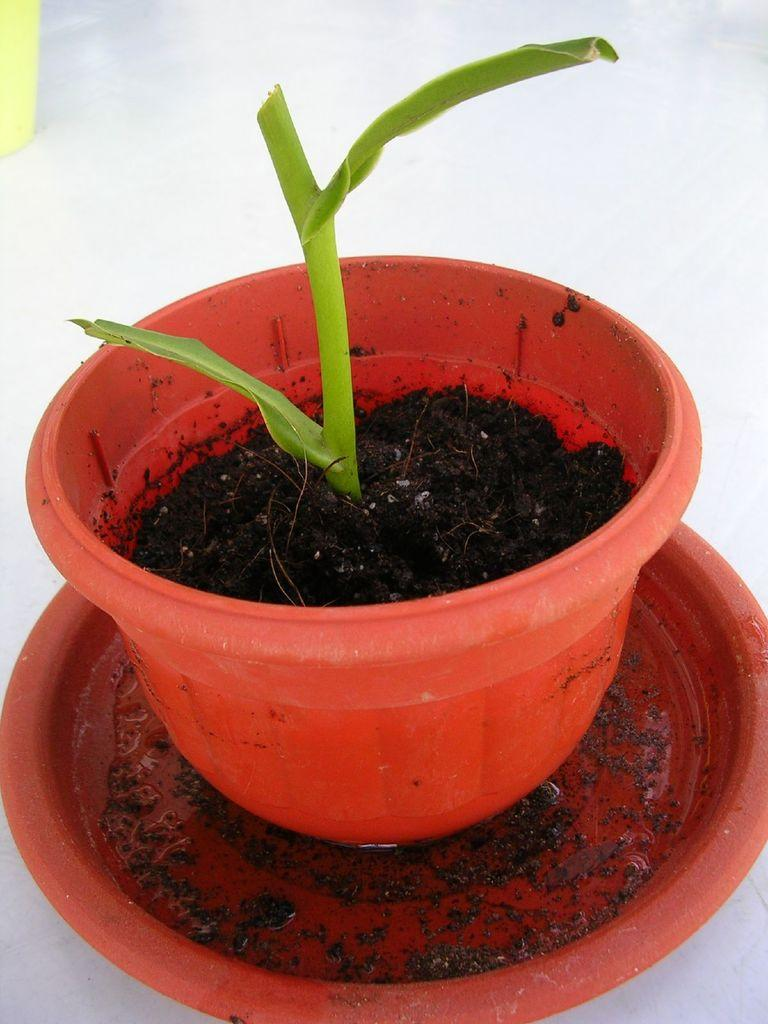What is in the bowl that is visible in the image? There is a plant in a bowl in the image. What is used to support the plant in the bowl? Soil is present in the bowl to support the plant. What is the flat, round object in the image? There is a plate in the image. Can you describe the object in the background of the image? There is an object in the background of the image, but its details are not clear from the provided facts. What type of gold material is used to make the seat in the image? There is no seat present in the image, and therefore no gold material can be observed. 